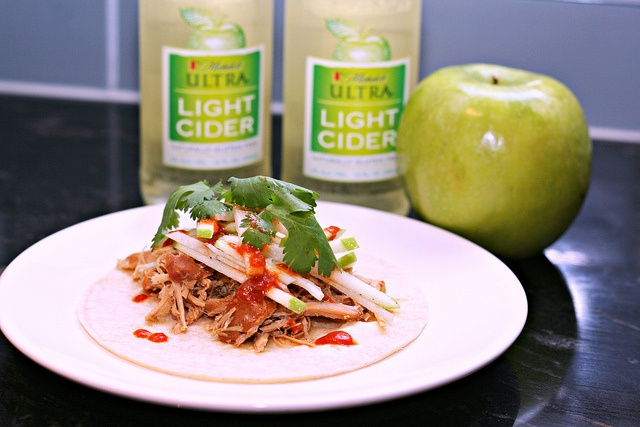Describe the objects in this image and their specific colors. I can see dining table in gray, black, purple, and darkblue tones, apple in gray, olive, tan, and black tones, bottle in gray, tan, and lightgray tones, and bottle in gray, tan, and lightgray tones in this image. 